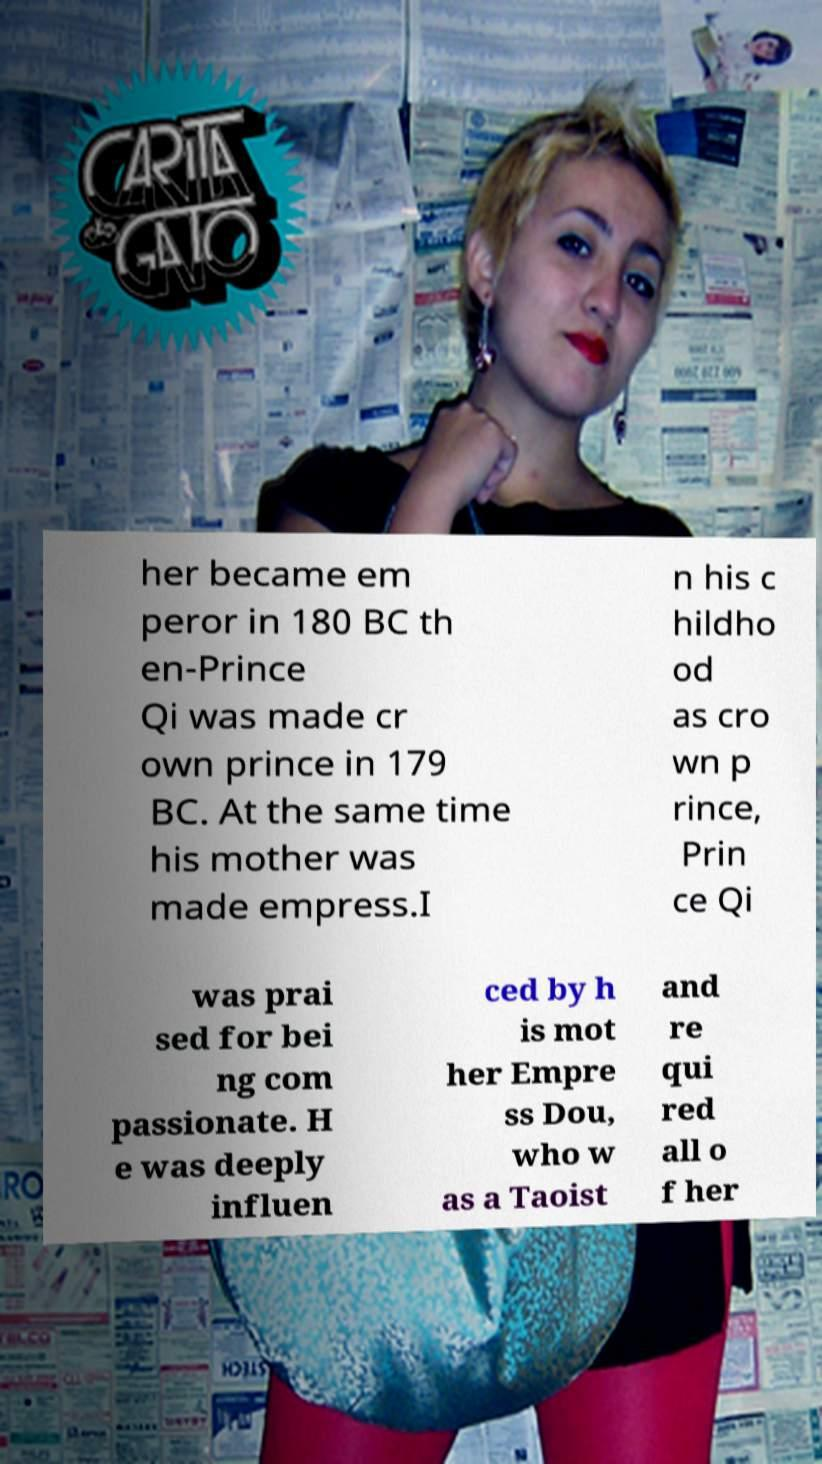Could you assist in decoding the text presented in this image and type it out clearly? her became em peror in 180 BC th en-Prince Qi was made cr own prince in 179 BC. At the same time his mother was made empress.I n his c hildho od as cro wn p rince, Prin ce Qi was prai sed for bei ng com passionate. H e was deeply influen ced by h is mot her Empre ss Dou, who w as a Taoist and re qui red all o f her 